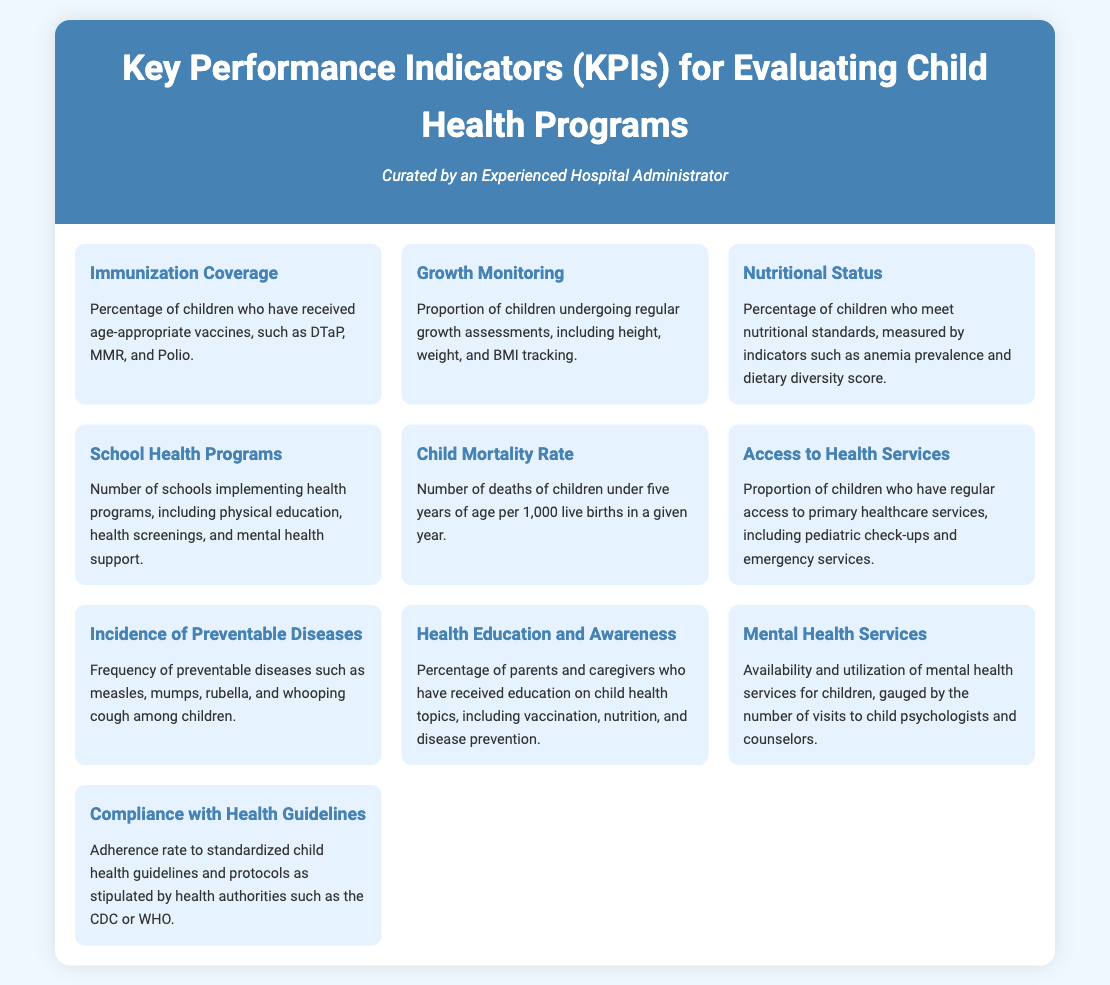What is the percentage for Immunization Coverage? Immunization Coverage is defined as the percentage of children who have received age-appropriate vaccines, which is not numerically specified in the document.
Answer: Not specified What is the definition of Growth Monitoring? Growth Monitoring is described as the proportion of children undergoing regular growth assessments, including height, weight, and BMI tracking.
Answer: Proportion of children undergoing regular growth assessments What is the key indicator for assessing Nutritional Status? Nutritional Status is assessed by the percentage of children who meet nutritional standards, measured by anemia prevalence and dietary diversity score.
Answer: Percentage of children who meet nutritional standards How many KPIs are listed in the document? The document lists ten key performance indicators for evaluating child health programs.
Answer: Ten What type of services does "Access to Health Services" refer to? Access to Health Services refers to primary healthcare services, including pediatric check-ups and emergency services available to children.
Answer: Primary healthcare services Which KPI evaluates the death rate of children under five years? The Child Mortality Rate is the KPI that measures the number of deaths of children under five years of age per 1,000 live births in a given year.
Answer: Child Mortality Rate What does the KPI for Mental Health Services assess? The Mental Health Services KPI gauges the availability and utilization of mental health services for children, measured by visits to child psychologists and counselors.
Answer: Availability and utilization of mental health services Which document section would you look for children's health education statistics? The section titled "Health Education and Awareness" describes the percentage of parents and caregivers who received education on child health topics.
Answer: Health Education and Awareness What is one of the KPIs related to school initiatives? "School Health Programs" measures the number of schools implementing health programs, including physical education and health screenings.
Answer: School Health Programs 